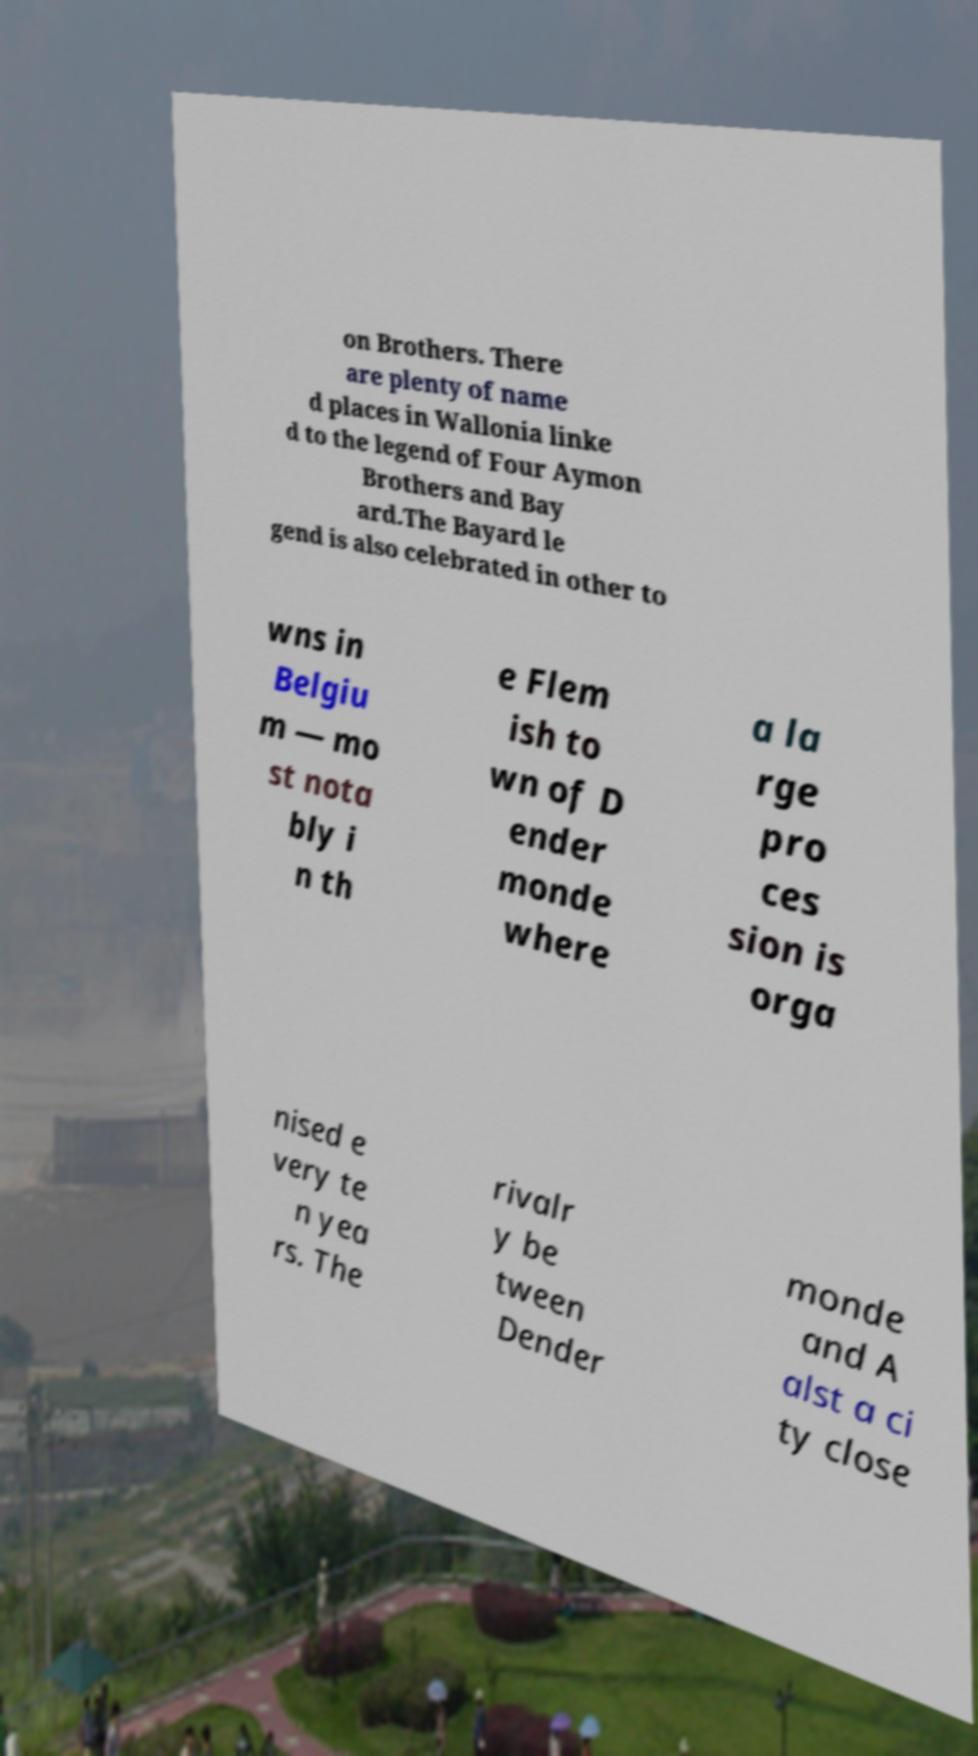What messages or text are displayed in this image? I need them in a readable, typed format. on Brothers. There are plenty of name d places in Wallonia linke d to the legend of Four Aymon Brothers and Bay ard.The Bayard le gend is also celebrated in other to wns in Belgiu m — mo st nota bly i n th e Flem ish to wn of D ender monde where a la rge pro ces sion is orga nised e very te n yea rs. The rivalr y be tween Dender monde and A alst a ci ty close 